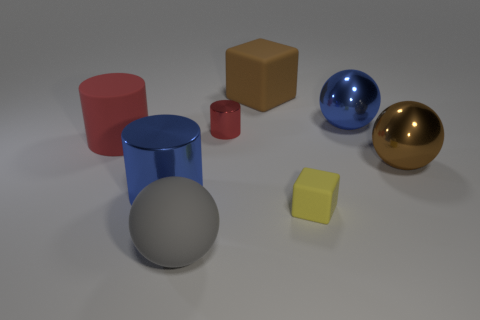Subtract all red cylinders. How many cylinders are left? 1 Subtract all brown blocks. How many red cylinders are left? 2 Add 1 small yellow objects. How many objects exist? 9 Subtract all cylinders. How many objects are left? 5 Subtract all red balls. Subtract all gray cylinders. How many balls are left? 3 Add 2 big blue metal cylinders. How many big blue metal cylinders are left? 3 Add 4 large metal things. How many large metal things exist? 7 Subtract 1 brown cubes. How many objects are left? 7 Subtract all big blue cylinders. Subtract all yellow matte blocks. How many objects are left? 6 